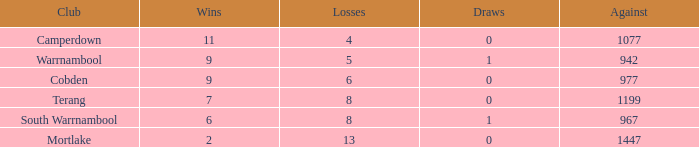What's the number of losses when the wins were more than 11 and had 0 draws? 0.0. 